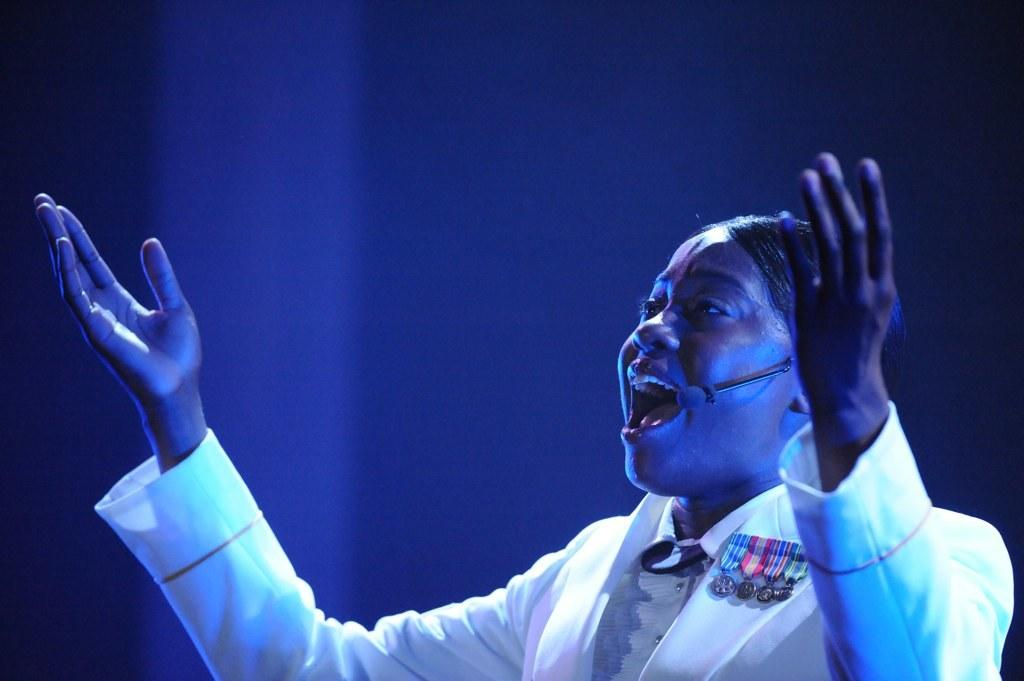Who or what is the main subject in the image? There is a person in the image. What is the person holding in the image? The person is holding a microphone. Can you describe any additional details about the person's attire? There is a badge on the person's dress. What color is the background of the image? The background of the image is blue. What type of bridge can be seen in the background of the image? There is no bridge present in the image; the background is blue. How many bananas are on the person's dress in the image? There are no bananas present on the person's dress in the image. 